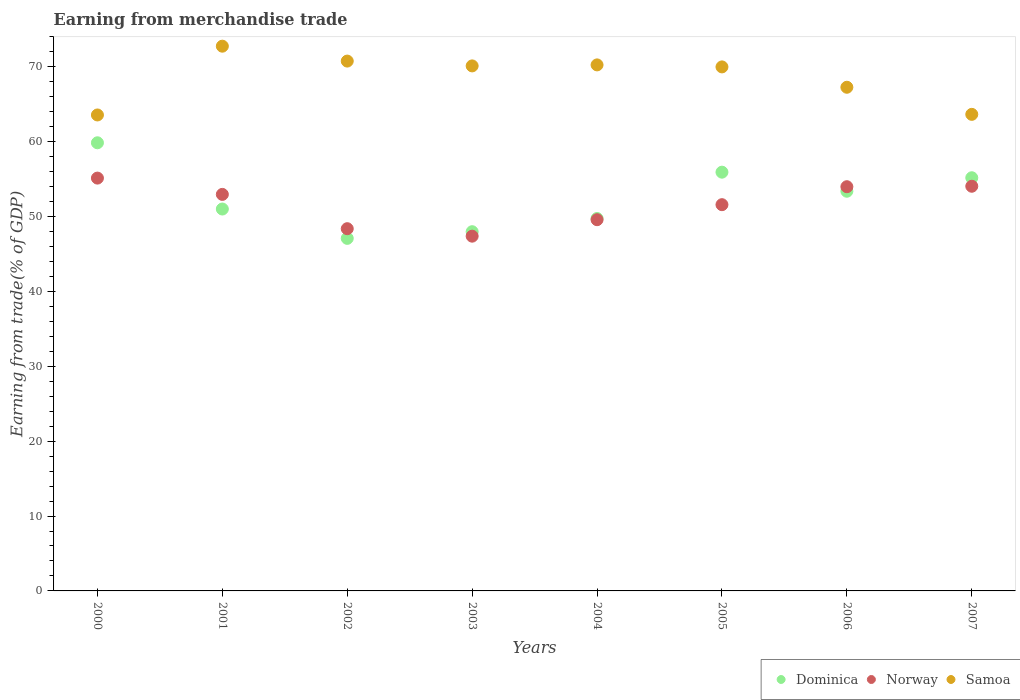What is the earnings from trade in Samoa in 2006?
Give a very brief answer. 67.26. Across all years, what is the maximum earnings from trade in Norway?
Ensure brevity in your answer.  55.13. Across all years, what is the minimum earnings from trade in Samoa?
Ensure brevity in your answer.  63.56. In which year was the earnings from trade in Samoa minimum?
Your answer should be very brief. 2000. What is the total earnings from trade in Samoa in the graph?
Offer a very short reply. 548.33. What is the difference between the earnings from trade in Samoa in 2000 and that in 2007?
Your answer should be compact. -0.08. What is the difference between the earnings from trade in Samoa in 2004 and the earnings from trade in Dominica in 2003?
Give a very brief answer. 22.28. What is the average earnings from trade in Samoa per year?
Your answer should be compact. 68.54. In the year 2003, what is the difference between the earnings from trade in Norway and earnings from trade in Dominica?
Provide a succinct answer. -0.6. In how many years, is the earnings from trade in Samoa greater than 8 %?
Offer a very short reply. 8. What is the ratio of the earnings from trade in Dominica in 2001 to that in 2007?
Keep it short and to the point. 0.92. What is the difference between the highest and the second highest earnings from trade in Norway?
Provide a succinct answer. 1.09. What is the difference between the highest and the lowest earnings from trade in Dominica?
Make the answer very short. 12.77. Is it the case that in every year, the sum of the earnings from trade in Samoa and earnings from trade in Dominica  is greater than the earnings from trade in Norway?
Your answer should be compact. Yes. Does the earnings from trade in Norway monotonically increase over the years?
Keep it short and to the point. No. Is the earnings from trade in Dominica strictly greater than the earnings from trade in Norway over the years?
Provide a short and direct response. No. Is the earnings from trade in Norway strictly less than the earnings from trade in Samoa over the years?
Provide a succinct answer. Yes. Are the values on the major ticks of Y-axis written in scientific E-notation?
Make the answer very short. No. Does the graph contain any zero values?
Your response must be concise. No. How many legend labels are there?
Offer a very short reply. 3. How are the legend labels stacked?
Offer a terse response. Horizontal. What is the title of the graph?
Your answer should be very brief. Earning from merchandise trade. Does "Malaysia" appear as one of the legend labels in the graph?
Provide a succinct answer. No. What is the label or title of the X-axis?
Give a very brief answer. Years. What is the label or title of the Y-axis?
Your response must be concise. Earning from trade(% of GDP). What is the Earning from trade(% of GDP) in Dominica in 2000?
Your answer should be compact. 59.85. What is the Earning from trade(% of GDP) in Norway in 2000?
Keep it short and to the point. 55.13. What is the Earning from trade(% of GDP) in Samoa in 2000?
Provide a succinct answer. 63.56. What is the Earning from trade(% of GDP) in Dominica in 2001?
Provide a short and direct response. 51. What is the Earning from trade(% of GDP) of Norway in 2001?
Make the answer very short. 52.96. What is the Earning from trade(% of GDP) in Samoa in 2001?
Offer a very short reply. 72.75. What is the Earning from trade(% of GDP) in Dominica in 2002?
Your answer should be compact. 47.08. What is the Earning from trade(% of GDP) in Norway in 2002?
Your answer should be compact. 48.38. What is the Earning from trade(% of GDP) of Samoa in 2002?
Your answer should be very brief. 70.76. What is the Earning from trade(% of GDP) in Dominica in 2003?
Your answer should be very brief. 47.97. What is the Earning from trade(% of GDP) of Norway in 2003?
Your answer should be compact. 47.38. What is the Earning from trade(% of GDP) in Samoa in 2003?
Ensure brevity in your answer.  70.12. What is the Earning from trade(% of GDP) in Dominica in 2004?
Your response must be concise. 49.74. What is the Earning from trade(% of GDP) of Norway in 2004?
Give a very brief answer. 49.58. What is the Earning from trade(% of GDP) in Samoa in 2004?
Your answer should be very brief. 70.25. What is the Earning from trade(% of GDP) in Dominica in 2005?
Provide a succinct answer. 55.92. What is the Earning from trade(% of GDP) in Norway in 2005?
Provide a short and direct response. 51.58. What is the Earning from trade(% of GDP) of Samoa in 2005?
Offer a terse response. 69.98. What is the Earning from trade(% of GDP) of Dominica in 2006?
Provide a short and direct response. 53.38. What is the Earning from trade(% of GDP) of Norway in 2006?
Give a very brief answer. 53.98. What is the Earning from trade(% of GDP) of Samoa in 2006?
Provide a succinct answer. 67.26. What is the Earning from trade(% of GDP) in Dominica in 2007?
Give a very brief answer. 55.18. What is the Earning from trade(% of GDP) of Norway in 2007?
Provide a short and direct response. 54.04. What is the Earning from trade(% of GDP) of Samoa in 2007?
Your answer should be very brief. 63.64. Across all years, what is the maximum Earning from trade(% of GDP) in Dominica?
Give a very brief answer. 59.85. Across all years, what is the maximum Earning from trade(% of GDP) in Norway?
Provide a succinct answer. 55.13. Across all years, what is the maximum Earning from trade(% of GDP) of Samoa?
Offer a terse response. 72.75. Across all years, what is the minimum Earning from trade(% of GDP) of Dominica?
Your answer should be very brief. 47.08. Across all years, what is the minimum Earning from trade(% of GDP) in Norway?
Give a very brief answer. 47.38. Across all years, what is the minimum Earning from trade(% of GDP) in Samoa?
Provide a short and direct response. 63.56. What is the total Earning from trade(% of GDP) in Dominica in the graph?
Give a very brief answer. 420.13. What is the total Earning from trade(% of GDP) of Norway in the graph?
Your answer should be very brief. 413.03. What is the total Earning from trade(% of GDP) in Samoa in the graph?
Give a very brief answer. 548.33. What is the difference between the Earning from trade(% of GDP) in Dominica in 2000 and that in 2001?
Provide a succinct answer. 8.85. What is the difference between the Earning from trade(% of GDP) in Norway in 2000 and that in 2001?
Offer a terse response. 2.18. What is the difference between the Earning from trade(% of GDP) in Samoa in 2000 and that in 2001?
Your answer should be compact. -9.19. What is the difference between the Earning from trade(% of GDP) in Dominica in 2000 and that in 2002?
Offer a very short reply. 12.77. What is the difference between the Earning from trade(% of GDP) in Norway in 2000 and that in 2002?
Your answer should be very brief. 6.76. What is the difference between the Earning from trade(% of GDP) of Samoa in 2000 and that in 2002?
Keep it short and to the point. -7.2. What is the difference between the Earning from trade(% of GDP) in Dominica in 2000 and that in 2003?
Offer a terse response. 11.88. What is the difference between the Earning from trade(% of GDP) of Norway in 2000 and that in 2003?
Your response must be concise. 7.76. What is the difference between the Earning from trade(% of GDP) in Samoa in 2000 and that in 2003?
Provide a short and direct response. -6.55. What is the difference between the Earning from trade(% of GDP) of Dominica in 2000 and that in 2004?
Your answer should be very brief. 10.11. What is the difference between the Earning from trade(% of GDP) in Norway in 2000 and that in 2004?
Ensure brevity in your answer.  5.55. What is the difference between the Earning from trade(% of GDP) of Samoa in 2000 and that in 2004?
Keep it short and to the point. -6.69. What is the difference between the Earning from trade(% of GDP) of Dominica in 2000 and that in 2005?
Your response must be concise. 3.93. What is the difference between the Earning from trade(% of GDP) of Norway in 2000 and that in 2005?
Give a very brief answer. 3.55. What is the difference between the Earning from trade(% of GDP) in Samoa in 2000 and that in 2005?
Your response must be concise. -6.42. What is the difference between the Earning from trade(% of GDP) in Dominica in 2000 and that in 2006?
Make the answer very short. 6.47. What is the difference between the Earning from trade(% of GDP) of Norway in 2000 and that in 2006?
Your answer should be compact. 1.15. What is the difference between the Earning from trade(% of GDP) of Samoa in 2000 and that in 2006?
Ensure brevity in your answer.  -3.7. What is the difference between the Earning from trade(% of GDP) in Dominica in 2000 and that in 2007?
Make the answer very short. 4.67. What is the difference between the Earning from trade(% of GDP) of Norway in 2000 and that in 2007?
Offer a terse response. 1.09. What is the difference between the Earning from trade(% of GDP) in Samoa in 2000 and that in 2007?
Offer a very short reply. -0.08. What is the difference between the Earning from trade(% of GDP) in Dominica in 2001 and that in 2002?
Ensure brevity in your answer.  3.92. What is the difference between the Earning from trade(% of GDP) in Norway in 2001 and that in 2002?
Keep it short and to the point. 4.58. What is the difference between the Earning from trade(% of GDP) in Samoa in 2001 and that in 2002?
Your answer should be compact. 1.99. What is the difference between the Earning from trade(% of GDP) of Dominica in 2001 and that in 2003?
Provide a short and direct response. 3.03. What is the difference between the Earning from trade(% of GDP) of Norway in 2001 and that in 2003?
Give a very brief answer. 5.58. What is the difference between the Earning from trade(% of GDP) in Samoa in 2001 and that in 2003?
Make the answer very short. 2.63. What is the difference between the Earning from trade(% of GDP) of Dominica in 2001 and that in 2004?
Offer a terse response. 1.26. What is the difference between the Earning from trade(% of GDP) in Norway in 2001 and that in 2004?
Your answer should be compact. 3.38. What is the difference between the Earning from trade(% of GDP) in Samoa in 2001 and that in 2004?
Your answer should be compact. 2.5. What is the difference between the Earning from trade(% of GDP) of Dominica in 2001 and that in 2005?
Provide a short and direct response. -4.92. What is the difference between the Earning from trade(% of GDP) in Norway in 2001 and that in 2005?
Offer a very short reply. 1.37. What is the difference between the Earning from trade(% of GDP) in Samoa in 2001 and that in 2005?
Provide a short and direct response. 2.77. What is the difference between the Earning from trade(% of GDP) in Dominica in 2001 and that in 2006?
Your answer should be compact. -2.37. What is the difference between the Earning from trade(% of GDP) of Norway in 2001 and that in 2006?
Your response must be concise. -1.03. What is the difference between the Earning from trade(% of GDP) of Samoa in 2001 and that in 2006?
Keep it short and to the point. 5.48. What is the difference between the Earning from trade(% of GDP) in Dominica in 2001 and that in 2007?
Provide a succinct answer. -4.18. What is the difference between the Earning from trade(% of GDP) of Norway in 2001 and that in 2007?
Your answer should be very brief. -1.09. What is the difference between the Earning from trade(% of GDP) in Samoa in 2001 and that in 2007?
Give a very brief answer. 9.1. What is the difference between the Earning from trade(% of GDP) in Dominica in 2002 and that in 2003?
Make the answer very short. -0.89. What is the difference between the Earning from trade(% of GDP) in Norway in 2002 and that in 2003?
Ensure brevity in your answer.  1. What is the difference between the Earning from trade(% of GDP) in Samoa in 2002 and that in 2003?
Make the answer very short. 0.64. What is the difference between the Earning from trade(% of GDP) of Dominica in 2002 and that in 2004?
Offer a very short reply. -2.65. What is the difference between the Earning from trade(% of GDP) of Norway in 2002 and that in 2004?
Your answer should be very brief. -1.2. What is the difference between the Earning from trade(% of GDP) of Samoa in 2002 and that in 2004?
Your answer should be compact. 0.51. What is the difference between the Earning from trade(% of GDP) in Dominica in 2002 and that in 2005?
Give a very brief answer. -8.84. What is the difference between the Earning from trade(% of GDP) in Norway in 2002 and that in 2005?
Your answer should be compact. -3.21. What is the difference between the Earning from trade(% of GDP) in Samoa in 2002 and that in 2005?
Ensure brevity in your answer.  0.78. What is the difference between the Earning from trade(% of GDP) of Dominica in 2002 and that in 2006?
Ensure brevity in your answer.  -6.29. What is the difference between the Earning from trade(% of GDP) in Norway in 2002 and that in 2006?
Your response must be concise. -5.61. What is the difference between the Earning from trade(% of GDP) in Samoa in 2002 and that in 2006?
Offer a very short reply. 3.5. What is the difference between the Earning from trade(% of GDP) of Dominica in 2002 and that in 2007?
Make the answer very short. -8.09. What is the difference between the Earning from trade(% of GDP) in Norway in 2002 and that in 2007?
Provide a short and direct response. -5.67. What is the difference between the Earning from trade(% of GDP) of Samoa in 2002 and that in 2007?
Ensure brevity in your answer.  7.12. What is the difference between the Earning from trade(% of GDP) of Dominica in 2003 and that in 2004?
Keep it short and to the point. -1.76. What is the difference between the Earning from trade(% of GDP) in Norway in 2003 and that in 2004?
Your answer should be very brief. -2.2. What is the difference between the Earning from trade(% of GDP) in Samoa in 2003 and that in 2004?
Offer a terse response. -0.14. What is the difference between the Earning from trade(% of GDP) of Dominica in 2003 and that in 2005?
Provide a succinct answer. -7.95. What is the difference between the Earning from trade(% of GDP) in Norway in 2003 and that in 2005?
Provide a short and direct response. -4.21. What is the difference between the Earning from trade(% of GDP) in Samoa in 2003 and that in 2005?
Provide a succinct answer. 0.13. What is the difference between the Earning from trade(% of GDP) in Dominica in 2003 and that in 2006?
Your answer should be compact. -5.4. What is the difference between the Earning from trade(% of GDP) of Norway in 2003 and that in 2006?
Give a very brief answer. -6.61. What is the difference between the Earning from trade(% of GDP) in Samoa in 2003 and that in 2006?
Offer a very short reply. 2.85. What is the difference between the Earning from trade(% of GDP) in Dominica in 2003 and that in 2007?
Your answer should be very brief. -7.2. What is the difference between the Earning from trade(% of GDP) of Norway in 2003 and that in 2007?
Make the answer very short. -6.67. What is the difference between the Earning from trade(% of GDP) in Samoa in 2003 and that in 2007?
Offer a terse response. 6.47. What is the difference between the Earning from trade(% of GDP) in Dominica in 2004 and that in 2005?
Your answer should be very brief. -6.19. What is the difference between the Earning from trade(% of GDP) in Norway in 2004 and that in 2005?
Your answer should be compact. -2.01. What is the difference between the Earning from trade(% of GDP) in Samoa in 2004 and that in 2005?
Keep it short and to the point. 0.27. What is the difference between the Earning from trade(% of GDP) in Dominica in 2004 and that in 2006?
Give a very brief answer. -3.64. What is the difference between the Earning from trade(% of GDP) in Norway in 2004 and that in 2006?
Offer a terse response. -4.41. What is the difference between the Earning from trade(% of GDP) in Samoa in 2004 and that in 2006?
Keep it short and to the point. 2.99. What is the difference between the Earning from trade(% of GDP) of Dominica in 2004 and that in 2007?
Offer a terse response. -5.44. What is the difference between the Earning from trade(% of GDP) in Norway in 2004 and that in 2007?
Your answer should be very brief. -4.47. What is the difference between the Earning from trade(% of GDP) of Samoa in 2004 and that in 2007?
Your response must be concise. 6.61. What is the difference between the Earning from trade(% of GDP) in Dominica in 2005 and that in 2006?
Your answer should be very brief. 2.55. What is the difference between the Earning from trade(% of GDP) in Norway in 2005 and that in 2006?
Your answer should be very brief. -2.4. What is the difference between the Earning from trade(% of GDP) in Samoa in 2005 and that in 2006?
Offer a very short reply. 2.72. What is the difference between the Earning from trade(% of GDP) in Dominica in 2005 and that in 2007?
Your answer should be compact. 0.75. What is the difference between the Earning from trade(% of GDP) of Norway in 2005 and that in 2007?
Keep it short and to the point. -2.46. What is the difference between the Earning from trade(% of GDP) of Samoa in 2005 and that in 2007?
Give a very brief answer. 6.34. What is the difference between the Earning from trade(% of GDP) of Dominica in 2006 and that in 2007?
Your answer should be very brief. -1.8. What is the difference between the Earning from trade(% of GDP) of Norway in 2006 and that in 2007?
Your answer should be compact. -0.06. What is the difference between the Earning from trade(% of GDP) of Samoa in 2006 and that in 2007?
Keep it short and to the point. 3.62. What is the difference between the Earning from trade(% of GDP) in Dominica in 2000 and the Earning from trade(% of GDP) in Norway in 2001?
Provide a succinct answer. 6.89. What is the difference between the Earning from trade(% of GDP) of Dominica in 2000 and the Earning from trade(% of GDP) of Samoa in 2001?
Ensure brevity in your answer.  -12.9. What is the difference between the Earning from trade(% of GDP) of Norway in 2000 and the Earning from trade(% of GDP) of Samoa in 2001?
Provide a succinct answer. -17.62. What is the difference between the Earning from trade(% of GDP) in Dominica in 2000 and the Earning from trade(% of GDP) in Norway in 2002?
Offer a terse response. 11.47. What is the difference between the Earning from trade(% of GDP) in Dominica in 2000 and the Earning from trade(% of GDP) in Samoa in 2002?
Make the answer very short. -10.91. What is the difference between the Earning from trade(% of GDP) in Norway in 2000 and the Earning from trade(% of GDP) in Samoa in 2002?
Provide a succinct answer. -15.63. What is the difference between the Earning from trade(% of GDP) in Dominica in 2000 and the Earning from trade(% of GDP) in Norway in 2003?
Your response must be concise. 12.47. What is the difference between the Earning from trade(% of GDP) in Dominica in 2000 and the Earning from trade(% of GDP) in Samoa in 2003?
Make the answer very short. -10.27. What is the difference between the Earning from trade(% of GDP) of Norway in 2000 and the Earning from trade(% of GDP) of Samoa in 2003?
Ensure brevity in your answer.  -14.98. What is the difference between the Earning from trade(% of GDP) in Dominica in 2000 and the Earning from trade(% of GDP) in Norway in 2004?
Give a very brief answer. 10.27. What is the difference between the Earning from trade(% of GDP) in Dominica in 2000 and the Earning from trade(% of GDP) in Samoa in 2004?
Ensure brevity in your answer.  -10.4. What is the difference between the Earning from trade(% of GDP) of Norway in 2000 and the Earning from trade(% of GDP) of Samoa in 2004?
Your response must be concise. -15.12. What is the difference between the Earning from trade(% of GDP) in Dominica in 2000 and the Earning from trade(% of GDP) in Norway in 2005?
Ensure brevity in your answer.  8.27. What is the difference between the Earning from trade(% of GDP) in Dominica in 2000 and the Earning from trade(% of GDP) in Samoa in 2005?
Ensure brevity in your answer.  -10.13. What is the difference between the Earning from trade(% of GDP) in Norway in 2000 and the Earning from trade(% of GDP) in Samoa in 2005?
Give a very brief answer. -14.85. What is the difference between the Earning from trade(% of GDP) of Dominica in 2000 and the Earning from trade(% of GDP) of Norway in 2006?
Give a very brief answer. 5.87. What is the difference between the Earning from trade(% of GDP) of Dominica in 2000 and the Earning from trade(% of GDP) of Samoa in 2006?
Give a very brief answer. -7.42. What is the difference between the Earning from trade(% of GDP) of Norway in 2000 and the Earning from trade(% of GDP) of Samoa in 2006?
Offer a very short reply. -12.13. What is the difference between the Earning from trade(% of GDP) in Dominica in 2000 and the Earning from trade(% of GDP) in Norway in 2007?
Make the answer very short. 5.81. What is the difference between the Earning from trade(% of GDP) in Dominica in 2000 and the Earning from trade(% of GDP) in Samoa in 2007?
Offer a terse response. -3.8. What is the difference between the Earning from trade(% of GDP) of Norway in 2000 and the Earning from trade(% of GDP) of Samoa in 2007?
Offer a very short reply. -8.51. What is the difference between the Earning from trade(% of GDP) of Dominica in 2001 and the Earning from trade(% of GDP) of Norway in 2002?
Provide a succinct answer. 2.63. What is the difference between the Earning from trade(% of GDP) in Dominica in 2001 and the Earning from trade(% of GDP) in Samoa in 2002?
Offer a very short reply. -19.76. What is the difference between the Earning from trade(% of GDP) of Norway in 2001 and the Earning from trade(% of GDP) of Samoa in 2002?
Make the answer very short. -17.8. What is the difference between the Earning from trade(% of GDP) in Dominica in 2001 and the Earning from trade(% of GDP) in Norway in 2003?
Ensure brevity in your answer.  3.63. What is the difference between the Earning from trade(% of GDP) in Dominica in 2001 and the Earning from trade(% of GDP) in Samoa in 2003?
Give a very brief answer. -19.11. What is the difference between the Earning from trade(% of GDP) of Norway in 2001 and the Earning from trade(% of GDP) of Samoa in 2003?
Your response must be concise. -17.16. What is the difference between the Earning from trade(% of GDP) of Dominica in 2001 and the Earning from trade(% of GDP) of Norway in 2004?
Give a very brief answer. 1.43. What is the difference between the Earning from trade(% of GDP) in Dominica in 2001 and the Earning from trade(% of GDP) in Samoa in 2004?
Offer a very short reply. -19.25. What is the difference between the Earning from trade(% of GDP) of Norway in 2001 and the Earning from trade(% of GDP) of Samoa in 2004?
Give a very brief answer. -17.29. What is the difference between the Earning from trade(% of GDP) in Dominica in 2001 and the Earning from trade(% of GDP) in Norway in 2005?
Offer a terse response. -0.58. What is the difference between the Earning from trade(% of GDP) of Dominica in 2001 and the Earning from trade(% of GDP) of Samoa in 2005?
Your response must be concise. -18.98. What is the difference between the Earning from trade(% of GDP) in Norway in 2001 and the Earning from trade(% of GDP) in Samoa in 2005?
Keep it short and to the point. -17.03. What is the difference between the Earning from trade(% of GDP) in Dominica in 2001 and the Earning from trade(% of GDP) in Norway in 2006?
Ensure brevity in your answer.  -2.98. What is the difference between the Earning from trade(% of GDP) in Dominica in 2001 and the Earning from trade(% of GDP) in Samoa in 2006?
Provide a short and direct response. -16.26. What is the difference between the Earning from trade(% of GDP) in Norway in 2001 and the Earning from trade(% of GDP) in Samoa in 2006?
Ensure brevity in your answer.  -14.31. What is the difference between the Earning from trade(% of GDP) of Dominica in 2001 and the Earning from trade(% of GDP) of Norway in 2007?
Offer a very short reply. -3.04. What is the difference between the Earning from trade(% of GDP) in Dominica in 2001 and the Earning from trade(% of GDP) in Samoa in 2007?
Ensure brevity in your answer.  -12.64. What is the difference between the Earning from trade(% of GDP) in Norway in 2001 and the Earning from trade(% of GDP) in Samoa in 2007?
Offer a very short reply. -10.69. What is the difference between the Earning from trade(% of GDP) of Dominica in 2002 and the Earning from trade(% of GDP) of Norway in 2003?
Your response must be concise. -0.29. What is the difference between the Earning from trade(% of GDP) in Dominica in 2002 and the Earning from trade(% of GDP) in Samoa in 2003?
Offer a terse response. -23.03. What is the difference between the Earning from trade(% of GDP) of Norway in 2002 and the Earning from trade(% of GDP) of Samoa in 2003?
Keep it short and to the point. -21.74. What is the difference between the Earning from trade(% of GDP) in Dominica in 2002 and the Earning from trade(% of GDP) in Norway in 2004?
Your response must be concise. -2.49. What is the difference between the Earning from trade(% of GDP) in Dominica in 2002 and the Earning from trade(% of GDP) in Samoa in 2004?
Offer a very short reply. -23.17. What is the difference between the Earning from trade(% of GDP) in Norway in 2002 and the Earning from trade(% of GDP) in Samoa in 2004?
Make the answer very short. -21.88. What is the difference between the Earning from trade(% of GDP) of Dominica in 2002 and the Earning from trade(% of GDP) of Norway in 2005?
Make the answer very short. -4.5. What is the difference between the Earning from trade(% of GDP) of Dominica in 2002 and the Earning from trade(% of GDP) of Samoa in 2005?
Ensure brevity in your answer.  -22.9. What is the difference between the Earning from trade(% of GDP) in Norway in 2002 and the Earning from trade(% of GDP) in Samoa in 2005?
Provide a succinct answer. -21.61. What is the difference between the Earning from trade(% of GDP) of Dominica in 2002 and the Earning from trade(% of GDP) of Norway in 2006?
Offer a terse response. -6.9. What is the difference between the Earning from trade(% of GDP) of Dominica in 2002 and the Earning from trade(% of GDP) of Samoa in 2006?
Make the answer very short. -20.18. What is the difference between the Earning from trade(% of GDP) in Norway in 2002 and the Earning from trade(% of GDP) in Samoa in 2006?
Keep it short and to the point. -18.89. What is the difference between the Earning from trade(% of GDP) of Dominica in 2002 and the Earning from trade(% of GDP) of Norway in 2007?
Offer a terse response. -6.96. What is the difference between the Earning from trade(% of GDP) in Dominica in 2002 and the Earning from trade(% of GDP) in Samoa in 2007?
Offer a very short reply. -16.56. What is the difference between the Earning from trade(% of GDP) in Norway in 2002 and the Earning from trade(% of GDP) in Samoa in 2007?
Offer a terse response. -15.27. What is the difference between the Earning from trade(% of GDP) of Dominica in 2003 and the Earning from trade(% of GDP) of Norway in 2004?
Your answer should be very brief. -1.6. What is the difference between the Earning from trade(% of GDP) of Dominica in 2003 and the Earning from trade(% of GDP) of Samoa in 2004?
Offer a very short reply. -22.28. What is the difference between the Earning from trade(% of GDP) in Norway in 2003 and the Earning from trade(% of GDP) in Samoa in 2004?
Give a very brief answer. -22.87. What is the difference between the Earning from trade(% of GDP) of Dominica in 2003 and the Earning from trade(% of GDP) of Norway in 2005?
Provide a succinct answer. -3.61. What is the difference between the Earning from trade(% of GDP) of Dominica in 2003 and the Earning from trade(% of GDP) of Samoa in 2005?
Keep it short and to the point. -22.01. What is the difference between the Earning from trade(% of GDP) in Norway in 2003 and the Earning from trade(% of GDP) in Samoa in 2005?
Ensure brevity in your answer.  -22.61. What is the difference between the Earning from trade(% of GDP) of Dominica in 2003 and the Earning from trade(% of GDP) of Norway in 2006?
Your response must be concise. -6.01. What is the difference between the Earning from trade(% of GDP) in Dominica in 2003 and the Earning from trade(% of GDP) in Samoa in 2006?
Offer a terse response. -19.29. What is the difference between the Earning from trade(% of GDP) of Norway in 2003 and the Earning from trade(% of GDP) of Samoa in 2006?
Keep it short and to the point. -19.89. What is the difference between the Earning from trade(% of GDP) of Dominica in 2003 and the Earning from trade(% of GDP) of Norway in 2007?
Provide a succinct answer. -6.07. What is the difference between the Earning from trade(% of GDP) of Dominica in 2003 and the Earning from trade(% of GDP) of Samoa in 2007?
Your response must be concise. -15.67. What is the difference between the Earning from trade(% of GDP) of Norway in 2003 and the Earning from trade(% of GDP) of Samoa in 2007?
Keep it short and to the point. -16.27. What is the difference between the Earning from trade(% of GDP) of Dominica in 2004 and the Earning from trade(% of GDP) of Norway in 2005?
Ensure brevity in your answer.  -1.84. What is the difference between the Earning from trade(% of GDP) in Dominica in 2004 and the Earning from trade(% of GDP) in Samoa in 2005?
Your answer should be very brief. -20.24. What is the difference between the Earning from trade(% of GDP) of Norway in 2004 and the Earning from trade(% of GDP) of Samoa in 2005?
Your response must be concise. -20.41. What is the difference between the Earning from trade(% of GDP) in Dominica in 2004 and the Earning from trade(% of GDP) in Norway in 2006?
Your response must be concise. -4.24. What is the difference between the Earning from trade(% of GDP) in Dominica in 2004 and the Earning from trade(% of GDP) in Samoa in 2006?
Provide a succinct answer. -17.53. What is the difference between the Earning from trade(% of GDP) of Norway in 2004 and the Earning from trade(% of GDP) of Samoa in 2006?
Ensure brevity in your answer.  -17.69. What is the difference between the Earning from trade(% of GDP) in Dominica in 2004 and the Earning from trade(% of GDP) in Norway in 2007?
Make the answer very short. -4.3. What is the difference between the Earning from trade(% of GDP) of Dominica in 2004 and the Earning from trade(% of GDP) of Samoa in 2007?
Your response must be concise. -13.91. What is the difference between the Earning from trade(% of GDP) of Norway in 2004 and the Earning from trade(% of GDP) of Samoa in 2007?
Ensure brevity in your answer.  -14.07. What is the difference between the Earning from trade(% of GDP) of Dominica in 2005 and the Earning from trade(% of GDP) of Norway in 2006?
Offer a terse response. 1.94. What is the difference between the Earning from trade(% of GDP) in Dominica in 2005 and the Earning from trade(% of GDP) in Samoa in 2006?
Ensure brevity in your answer.  -11.34. What is the difference between the Earning from trade(% of GDP) in Norway in 2005 and the Earning from trade(% of GDP) in Samoa in 2006?
Offer a very short reply. -15.68. What is the difference between the Earning from trade(% of GDP) of Dominica in 2005 and the Earning from trade(% of GDP) of Norway in 2007?
Your answer should be compact. 1.88. What is the difference between the Earning from trade(% of GDP) in Dominica in 2005 and the Earning from trade(% of GDP) in Samoa in 2007?
Keep it short and to the point. -7.72. What is the difference between the Earning from trade(% of GDP) in Norway in 2005 and the Earning from trade(% of GDP) in Samoa in 2007?
Keep it short and to the point. -12.06. What is the difference between the Earning from trade(% of GDP) in Dominica in 2006 and the Earning from trade(% of GDP) in Norway in 2007?
Ensure brevity in your answer.  -0.67. What is the difference between the Earning from trade(% of GDP) in Dominica in 2006 and the Earning from trade(% of GDP) in Samoa in 2007?
Your answer should be very brief. -10.27. What is the difference between the Earning from trade(% of GDP) of Norway in 2006 and the Earning from trade(% of GDP) of Samoa in 2007?
Make the answer very short. -9.66. What is the average Earning from trade(% of GDP) in Dominica per year?
Make the answer very short. 52.52. What is the average Earning from trade(% of GDP) of Norway per year?
Keep it short and to the point. 51.63. What is the average Earning from trade(% of GDP) in Samoa per year?
Your answer should be compact. 68.54. In the year 2000, what is the difference between the Earning from trade(% of GDP) of Dominica and Earning from trade(% of GDP) of Norway?
Your response must be concise. 4.72. In the year 2000, what is the difference between the Earning from trade(% of GDP) of Dominica and Earning from trade(% of GDP) of Samoa?
Provide a short and direct response. -3.72. In the year 2000, what is the difference between the Earning from trade(% of GDP) in Norway and Earning from trade(% of GDP) in Samoa?
Make the answer very short. -8.43. In the year 2001, what is the difference between the Earning from trade(% of GDP) in Dominica and Earning from trade(% of GDP) in Norway?
Ensure brevity in your answer.  -1.95. In the year 2001, what is the difference between the Earning from trade(% of GDP) of Dominica and Earning from trade(% of GDP) of Samoa?
Offer a terse response. -21.75. In the year 2001, what is the difference between the Earning from trade(% of GDP) in Norway and Earning from trade(% of GDP) in Samoa?
Your response must be concise. -19.79. In the year 2002, what is the difference between the Earning from trade(% of GDP) of Dominica and Earning from trade(% of GDP) of Norway?
Ensure brevity in your answer.  -1.29. In the year 2002, what is the difference between the Earning from trade(% of GDP) in Dominica and Earning from trade(% of GDP) in Samoa?
Provide a succinct answer. -23.68. In the year 2002, what is the difference between the Earning from trade(% of GDP) of Norway and Earning from trade(% of GDP) of Samoa?
Give a very brief answer. -22.38. In the year 2003, what is the difference between the Earning from trade(% of GDP) in Dominica and Earning from trade(% of GDP) in Norway?
Give a very brief answer. 0.6. In the year 2003, what is the difference between the Earning from trade(% of GDP) in Dominica and Earning from trade(% of GDP) in Samoa?
Keep it short and to the point. -22.14. In the year 2003, what is the difference between the Earning from trade(% of GDP) in Norway and Earning from trade(% of GDP) in Samoa?
Your answer should be very brief. -22.74. In the year 2004, what is the difference between the Earning from trade(% of GDP) of Dominica and Earning from trade(% of GDP) of Norway?
Make the answer very short. 0.16. In the year 2004, what is the difference between the Earning from trade(% of GDP) of Dominica and Earning from trade(% of GDP) of Samoa?
Ensure brevity in your answer.  -20.51. In the year 2004, what is the difference between the Earning from trade(% of GDP) in Norway and Earning from trade(% of GDP) in Samoa?
Make the answer very short. -20.67. In the year 2005, what is the difference between the Earning from trade(% of GDP) of Dominica and Earning from trade(% of GDP) of Norway?
Ensure brevity in your answer.  4.34. In the year 2005, what is the difference between the Earning from trade(% of GDP) of Dominica and Earning from trade(% of GDP) of Samoa?
Provide a short and direct response. -14.06. In the year 2005, what is the difference between the Earning from trade(% of GDP) in Norway and Earning from trade(% of GDP) in Samoa?
Ensure brevity in your answer.  -18.4. In the year 2006, what is the difference between the Earning from trade(% of GDP) in Dominica and Earning from trade(% of GDP) in Norway?
Offer a very short reply. -0.61. In the year 2006, what is the difference between the Earning from trade(% of GDP) of Dominica and Earning from trade(% of GDP) of Samoa?
Give a very brief answer. -13.89. In the year 2006, what is the difference between the Earning from trade(% of GDP) of Norway and Earning from trade(% of GDP) of Samoa?
Offer a very short reply. -13.28. In the year 2007, what is the difference between the Earning from trade(% of GDP) in Dominica and Earning from trade(% of GDP) in Norway?
Your response must be concise. 1.14. In the year 2007, what is the difference between the Earning from trade(% of GDP) in Dominica and Earning from trade(% of GDP) in Samoa?
Provide a short and direct response. -8.47. In the year 2007, what is the difference between the Earning from trade(% of GDP) of Norway and Earning from trade(% of GDP) of Samoa?
Offer a terse response. -9.6. What is the ratio of the Earning from trade(% of GDP) of Dominica in 2000 to that in 2001?
Offer a very short reply. 1.17. What is the ratio of the Earning from trade(% of GDP) of Norway in 2000 to that in 2001?
Ensure brevity in your answer.  1.04. What is the ratio of the Earning from trade(% of GDP) in Samoa in 2000 to that in 2001?
Make the answer very short. 0.87. What is the ratio of the Earning from trade(% of GDP) of Dominica in 2000 to that in 2002?
Your answer should be compact. 1.27. What is the ratio of the Earning from trade(% of GDP) in Norway in 2000 to that in 2002?
Your response must be concise. 1.14. What is the ratio of the Earning from trade(% of GDP) of Samoa in 2000 to that in 2002?
Offer a very short reply. 0.9. What is the ratio of the Earning from trade(% of GDP) in Dominica in 2000 to that in 2003?
Give a very brief answer. 1.25. What is the ratio of the Earning from trade(% of GDP) in Norway in 2000 to that in 2003?
Offer a terse response. 1.16. What is the ratio of the Earning from trade(% of GDP) of Samoa in 2000 to that in 2003?
Offer a very short reply. 0.91. What is the ratio of the Earning from trade(% of GDP) of Dominica in 2000 to that in 2004?
Ensure brevity in your answer.  1.2. What is the ratio of the Earning from trade(% of GDP) of Norway in 2000 to that in 2004?
Your answer should be very brief. 1.11. What is the ratio of the Earning from trade(% of GDP) in Samoa in 2000 to that in 2004?
Your response must be concise. 0.9. What is the ratio of the Earning from trade(% of GDP) in Dominica in 2000 to that in 2005?
Provide a succinct answer. 1.07. What is the ratio of the Earning from trade(% of GDP) of Norway in 2000 to that in 2005?
Your response must be concise. 1.07. What is the ratio of the Earning from trade(% of GDP) in Samoa in 2000 to that in 2005?
Give a very brief answer. 0.91. What is the ratio of the Earning from trade(% of GDP) in Dominica in 2000 to that in 2006?
Offer a very short reply. 1.12. What is the ratio of the Earning from trade(% of GDP) of Norway in 2000 to that in 2006?
Offer a very short reply. 1.02. What is the ratio of the Earning from trade(% of GDP) in Samoa in 2000 to that in 2006?
Your response must be concise. 0.94. What is the ratio of the Earning from trade(% of GDP) of Dominica in 2000 to that in 2007?
Provide a succinct answer. 1.08. What is the ratio of the Earning from trade(% of GDP) of Norway in 2000 to that in 2007?
Your response must be concise. 1.02. What is the ratio of the Earning from trade(% of GDP) of Dominica in 2001 to that in 2002?
Ensure brevity in your answer.  1.08. What is the ratio of the Earning from trade(% of GDP) in Norway in 2001 to that in 2002?
Your response must be concise. 1.09. What is the ratio of the Earning from trade(% of GDP) of Samoa in 2001 to that in 2002?
Provide a short and direct response. 1.03. What is the ratio of the Earning from trade(% of GDP) in Dominica in 2001 to that in 2003?
Offer a terse response. 1.06. What is the ratio of the Earning from trade(% of GDP) in Norway in 2001 to that in 2003?
Give a very brief answer. 1.12. What is the ratio of the Earning from trade(% of GDP) in Samoa in 2001 to that in 2003?
Offer a terse response. 1.04. What is the ratio of the Earning from trade(% of GDP) of Dominica in 2001 to that in 2004?
Give a very brief answer. 1.03. What is the ratio of the Earning from trade(% of GDP) in Norway in 2001 to that in 2004?
Offer a very short reply. 1.07. What is the ratio of the Earning from trade(% of GDP) of Samoa in 2001 to that in 2004?
Keep it short and to the point. 1.04. What is the ratio of the Earning from trade(% of GDP) in Dominica in 2001 to that in 2005?
Your answer should be very brief. 0.91. What is the ratio of the Earning from trade(% of GDP) of Norway in 2001 to that in 2005?
Give a very brief answer. 1.03. What is the ratio of the Earning from trade(% of GDP) in Samoa in 2001 to that in 2005?
Provide a succinct answer. 1.04. What is the ratio of the Earning from trade(% of GDP) of Dominica in 2001 to that in 2006?
Provide a short and direct response. 0.96. What is the ratio of the Earning from trade(% of GDP) in Samoa in 2001 to that in 2006?
Your answer should be very brief. 1.08. What is the ratio of the Earning from trade(% of GDP) in Dominica in 2001 to that in 2007?
Give a very brief answer. 0.92. What is the ratio of the Earning from trade(% of GDP) of Norway in 2001 to that in 2007?
Your answer should be compact. 0.98. What is the ratio of the Earning from trade(% of GDP) in Samoa in 2001 to that in 2007?
Give a very brief answer. 1.14. What is the ratio of the Earning from trade(% of GDP) of Dominica in 2002 to that in 2003?
Your answer should be very brief. 0.98. What is the ratio of the Earning from trade(% of GDP) of Norway in 2002 to that in 2003?
Your answer should be compact. 1.02. What is the ratio of the Earning from trade(% of GDP) of Samoa in 2002 to that in 2003?
Provide a short and direct response. 1.01. What is the ratio of the Earning from trade(% of GDP) of Dominica in 2002 to that in 2004?
Your response must be concise. 0.95. What is the ratio of the Earning from trade(% of GDP) in Norway in 2002 to that in 2004?
Your response must be concise. 0.98. What is the ratio of the Earning from trade(% of GDP) in Dominica in 2002 to that in 2005?
Your response must be concise. 0.84. What is the ratio of the Earning from trade(% of GDP) in Norway in 2002 to that in 2005?
Give a very brief answer. 0.94. What is the ratio of the Earning from trade(% of GDP) of Samoa in 2002 to that in 2005?
Your answer should be compact. 1.01. What is the ratio of the Earning from trade(% of GDP) in Dominica in 2002 to that in 2006?
Offer a very short reply. 0.88. What is the ratio of the Earning from trade(% of GDP) of Norway in 2002 to that in 2006?
Offer a terse response. 0.9. What is the ratio of the Earning from trade(% of GDP) of Samoa in 2002 to that in 2006?
Provide a succinct answer. 1.05. What is the ratio of the Earning from trade(% of GDP) in Dominica in 2002 to that in 2007?
Ensure brevity in your answer.  0.85. What is the ratio of the Earning from trade(% of GDP) in Norway in 2002 to that in 2007?
Provide a succinct answer. 0.9. What is the ratio of the Earning from trade(% of GDP) of Samoa in 2002 to that in 2007?
Make the answer very short. 1.11. What is the ratio of the Earning from trade(% of GDP) in Dominica in 2003 to that in 2004?
Provide a short and direct response. 0.96. What is the ratio of the Earning from trade(% of GDP) of Norway in 2003 to that in 2004?
Your response must be concise. 0.96. What is the ratio of the Earning from trade(% of GDP) of Samoa in 2003 to that in 2004?
Your answer should be compact. 1. What is the ratio of the Earning from trade(% of GDP) in Dominica in 2003 to that in 2005?
Your answer should be compact. 0.86. What is the ratio of the Earning from trade(% of GDP) of Norway in 2003 to that in 2005?
Keep it short and to the point. 0.92. What is the ratio of the Earning from trade(% of GDP) of Dominica in 2003 to that in 2006?
Offer a terse response. 0.9. What is the ratio of the Earning from trade(% of GDP) of Norway in 2003 to that in 2006?
Offer a very short reply. 0.88. What is the ratio of the Earning from trade(% of GDP) in Samoa in 2003 to that in 2006?
Ensure brevity in your answer.  1.04. What is the ratio of the Earning from trade(% of GDP) in Dominica in 2003 to that in 2007?
Provide a succinct answer. 0.87. What is the ratio of the Earning from trade(% of GDP) of Norway in 2003 to that in 2007?
Offer a terse response. 0.88. What is the ratio of the Earning from trade(% of GDP) of Samoa in 2003 to that in 2007?
Ensure brevity in your answer.  1.1. What is the ratio of the Earning from trade(% of GDP) of Dominica in 2004 to that in 2005?
Ensure brevity in your answer.  0.89. What is the ratio of the Earning from trade(% of GDP) in Norway in 2004 to that in 2005?
Make the answer very short. 0.96. What is the ratio of the Earning from trade(% of GDP) of Dominica in 2004 to that in 2006?
Make the answer very short. 0.93. What is the ratio of the Earning from trade(% of GDP) of Norway in 2004 to that in 2006?
Provide a short and direct response. 0.92. What is the ratio of the Earning from trade(% of GDP) in Samoa in 2004 to that in 2006?
Offer a very short reply. 1.04. What is the ratio of the Earning from trade(% of GDP) in Dominica in 2004 to that in 2007?
Your response must be concise. 0.9. What is the ratio of the Earning from trade(% of GDP) of Norway in 2004 to that in 2007?
Provide a succinct answer. 0.92. What is the ratio of the Earning from trade(% of GDP) of Samoa in 2004 to that in 2007?
Give a very brief answer. 1.1. What is the ratio of the Earning from trade(% of GDP) in Dominica in 2005 to that in 2006?
Ensure brevity in your answer.  1.05. What is the ratio of the Earning from trade(% of GDP) in Norway in 2005 to that in 2006?
Offer a very short reply. 0.96. What is the ratio of the Earning from trade(% of GDP) of Samoa in 2005 to that in 2006?
Your answer should be very brief. 1.04. What is the ratio of the Earning from trade(% of GDP) in Dominica in 2005 to that in 2007?
Keep it short and to the point. 1.01. What is the ratio of the Earning from trade(% of GDP) in Norway in 2005 to that in 2007?
Your response must be concise. 0.95. What is the ratio of the Earning from trade(% of GDP) in Samoa in 2005 to that in 2007?
Provide a succinct answer. 1.1. What is the ratio of the Earning from trade(% of GDP) of Dominica in 2006 to that in 2007?
Give a very brief answer. 0.97. What is the ratio of the Earning from trade(% of GDP) in Samoa in 2006 to that in 2007?
Offer a very short reply. 1.06. What is the difference between the highest and the second highest Earning from trade(% of GDP) of Dominica?
Your answer should be very brief. 3.93. What is the difference between the highest and the second highest Earning from trade(% of GDP) in Norway?
Make the answer very short. 1.09. What is the difference between the highest and the second highest Earning from trade(% of GDP) in Samoa?
Keep it short and to the point. 1.99. What is the difference between the highest and the lowest Earning from trade(% of GDP) in Dominica?
Offer a terse response. 12.77. What is the difference between the highest and the lowest Earning from trade(% of GDP) of Norway?
Your answer should be compact. 7.76. What is the difference between the highest and the lowest Earning from trade(% of GDP) in Samoa?
Make the answer very short. 9.19. 